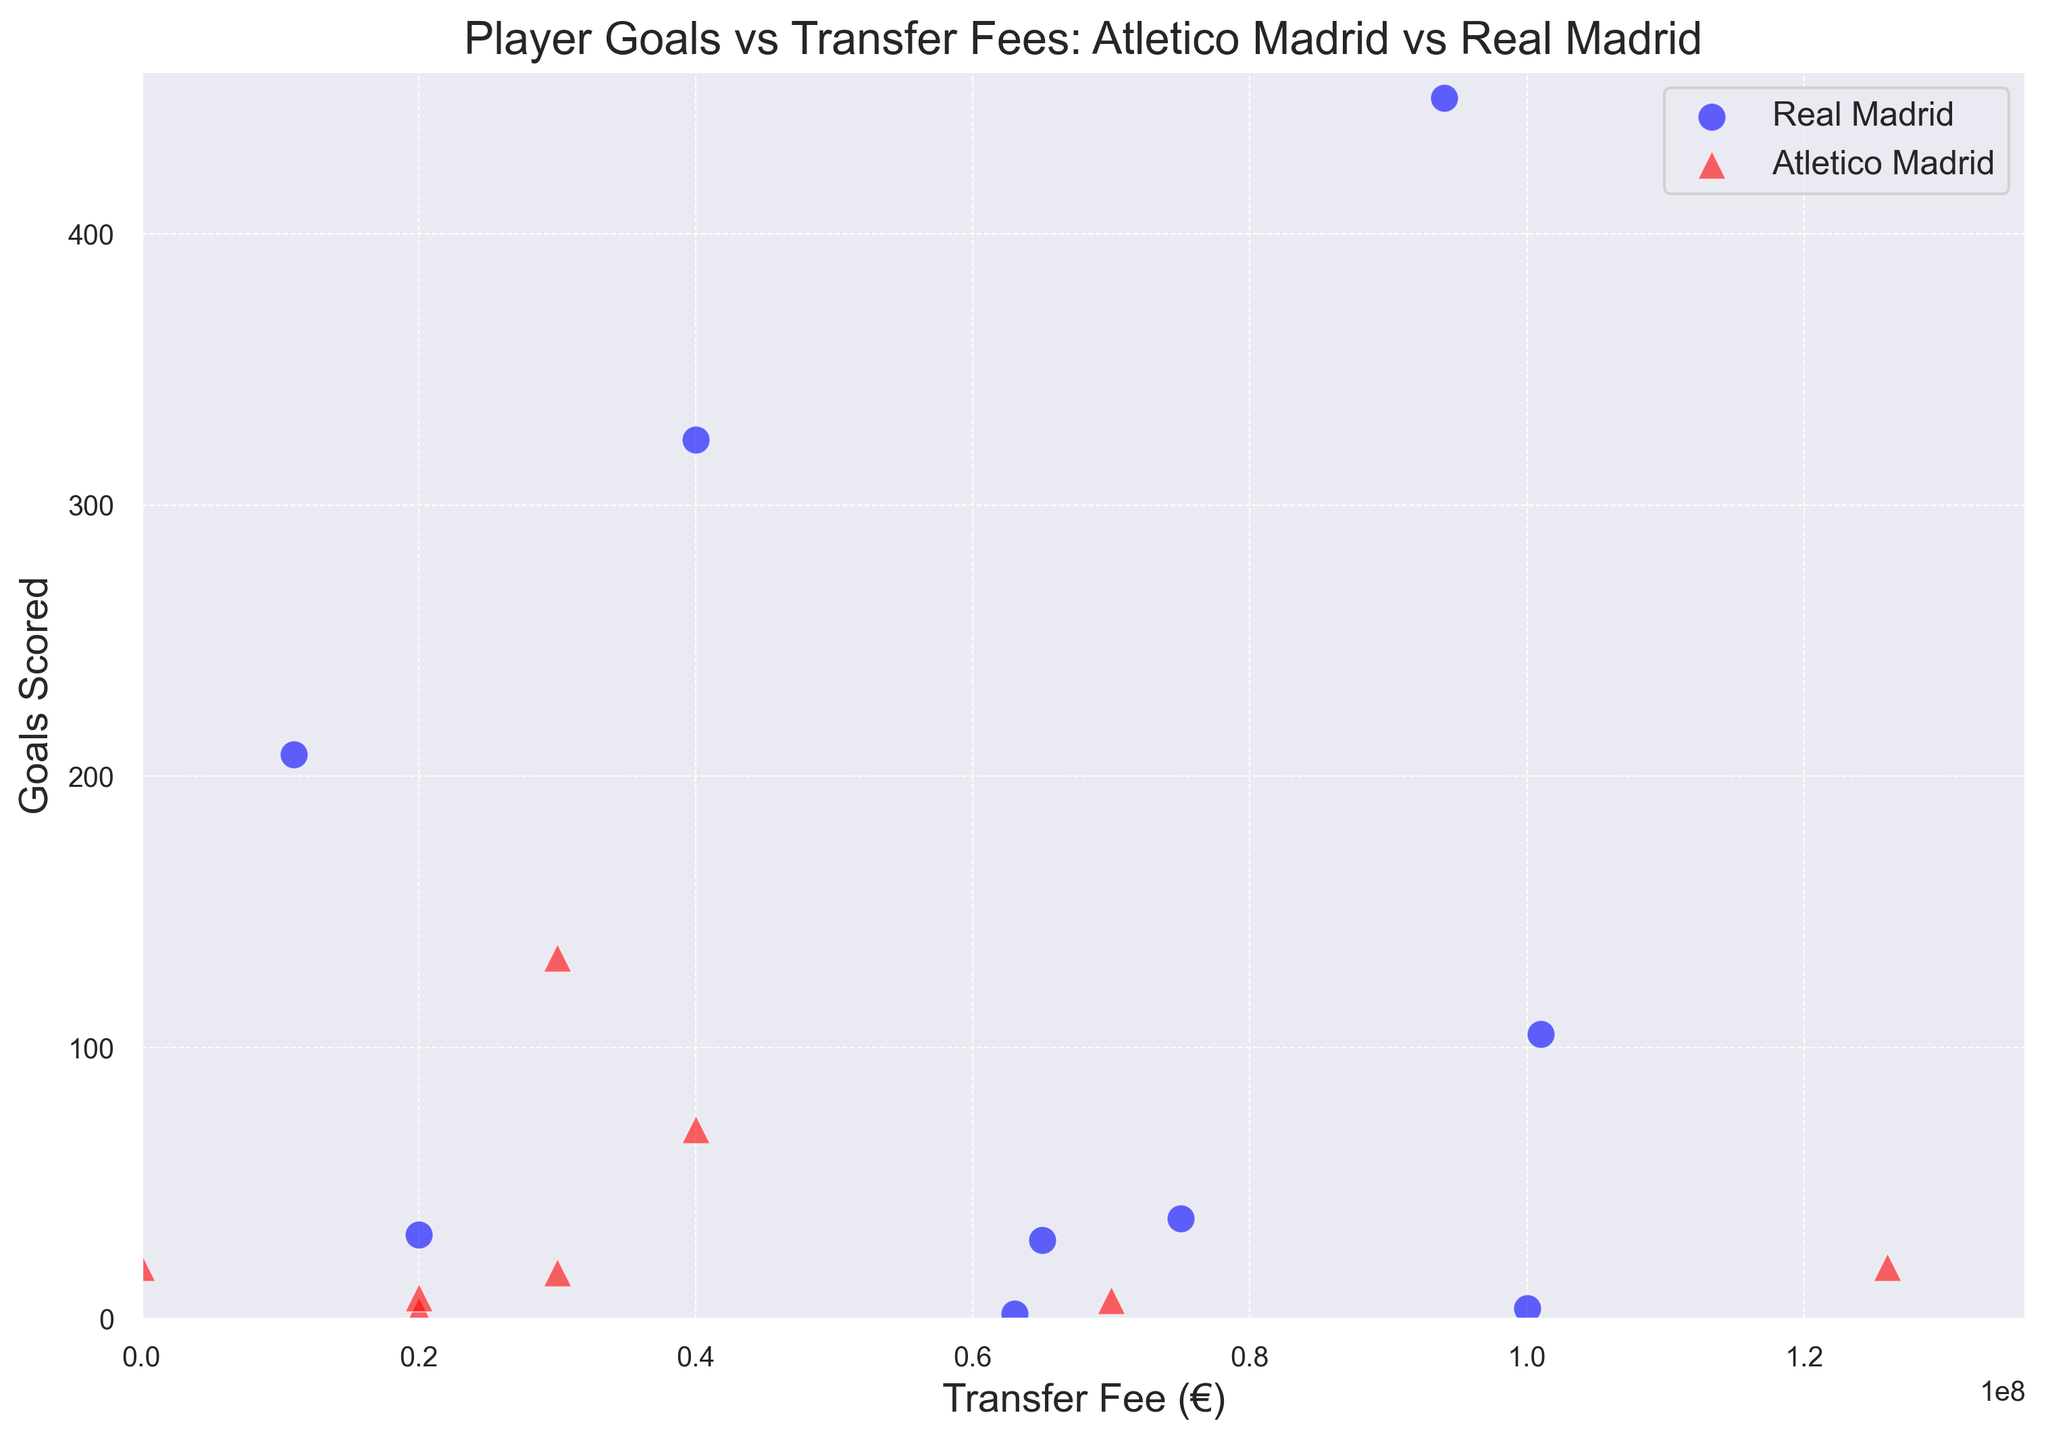What's the total number of goals scored by Real Madrid players whose transfer fees are over €75,000,000? First, identify the Real Madrid players with transfer fees over €75,000,000. These are Cristiano Ronaldo (450 goals), Gareth Bale (105 goals), Eden Hazard (4 goals), and James Rodriguez (37 goals). Add their goals: 450 + 105 + 4 + 37.
Answer: 596 Which Atletico Madrid player has the highest transfer fee and how many goals has he scored? Joao Felix has the highest transfer fee among Atletico Madrid players at €126,000,000. According to the chart, he has scored 19 goals.
Answer: Joao Felix, 19 goals How does Hugo Sanchez's goals per transfer fee compare to Thomas Lemar's? Hugo Sanchez (Real Madrid) had a transfer fee of €11,000,000 and scored 208 goals, resulting in 208/11 = 18.91 goals per million euros. Thomas Lemar (Atletico Madrid) had a transfer fee of €70,000,000 and scored 7 goals, resulting in 7/70 = 0.1 goals per million euros. Sanchez's efficiency is far higher.
Answer: Hugo Sanchez: 18.91 goals/million euros, Thomas Lemar: 0.1 goals/million euros Which club has the player with the highest number of goals scored, and who is the player? According to the chart, Cristiano Ronaldo from Real Madrid has scored the highest number of goals, 450.
Answer: Real Madrid, Cristiano Ronaldo What is the average transfer fee of Atletico Madrid players shown in the dataset? List the transfer fees of Atletico Madrid players: 126,000,000 (Joao Felix), 70,000,000 (Thomas Lemar), 20,000,000 (Rodrigo Hernandez), 30,000,000 (Antoine Griezmann), 30,000,000 (Marcos Llorente), 40,000,000 (Radamel Falcao), and 20,000,000 (Filipe Luis). Calculate the sum: 126 + 70 + 20 + 30 + 30 + 40 + 20 = 336. Divide by number of players: 336/7 ≈ 48,000,000.
Answer: 48,000,000 Who has a higher goals per appearance ratio, Karim Benzema or Antoine Griezmann? Karim Benzema (324 goals in 718 appearances) has a ratio of 324/718 ≈ 0.45. Antoine Griezmann (133 goals in 257 appearances) has a ratio of 133/257 ≈ 0.52. Griezmann's ratio is higher.
Answer: Antoine Griezmann Which club's player contributes more to assists, based on the largest single value? Karim Benzema from Real Madrid has the highest number of assists at 165, which is higher than any assist value attributed to any player from Atletico Madrid on the chart.
Answer: Real Madrid What does the ratio of transfer fee to appearances indicate for Luka Jovic and Rodrigo Hernandez? Luka Jovic's transfer fee of €63,000,000 and 21 appearances give a ratio of 63/21 = 3 million euros per appearance. Rodrigo Hernandez's transfer fee of €20,000,000 and 47 appearances give a ratio of 20/47 ≈ 0.43 million euros per appearance. Jovic's ratio indicates a higher cost per appearance.
Answer: Luka Jovic: 3 million euros/appearance, Rodrigo Hernandez: 0.43 million euros/appearance 